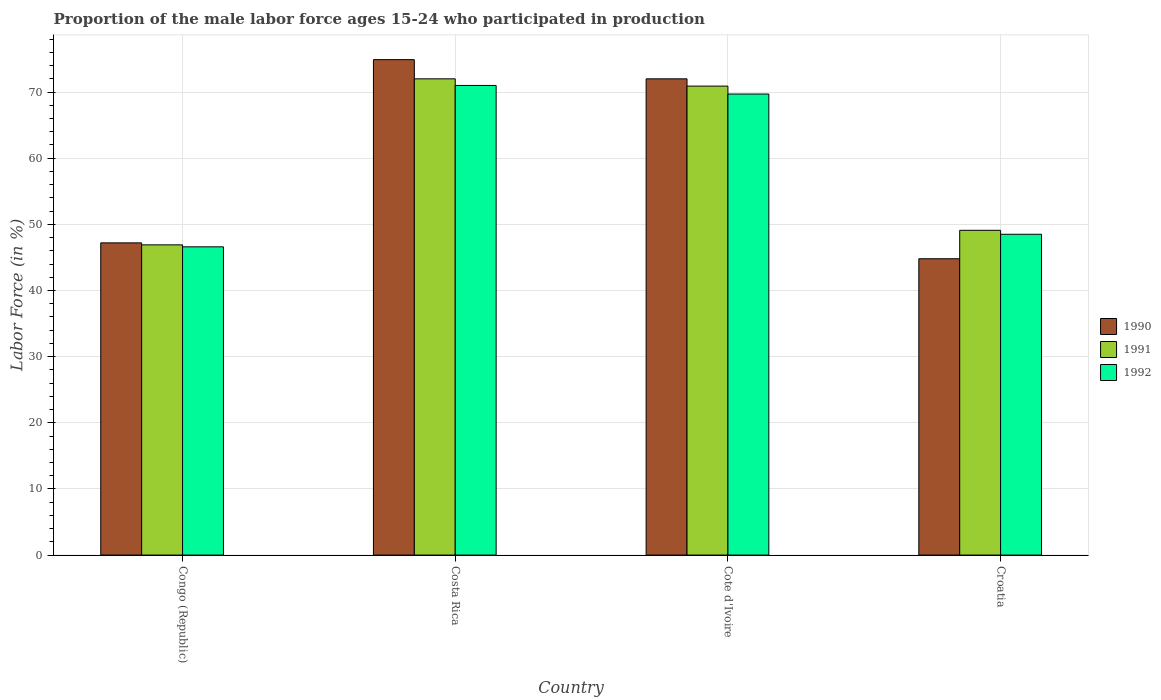How many groups of bars are there?
Provide a succinct answer. 4. How many bars are there on the 4th tick from the left?
Give a very brief answer. 3. What is the label of the 2nd group of bars from the left?
Ensure brevity in your answer.  Costa Rica. What is the proportion of the male labor force who participated in production in 1991 in Croatia?
Offer a terse response. 49.1. Across all countries, what is the minimum proportion of the male labor force who participated in production in 1991?
Your response must be concise. 46.9. In which country was the proportion of the male labor force who participated in production in 1992 minimum?
Offer a very short reply. Congo (Republic). What is the total proportion of the male labor force who participated in production in 1992 in the graph?
Offer a terse response. 235.8. What is the difference between the proportion of the male labor force who participated in production in 1992 in Congo (Republic) and that in Cote d'Ivoire?
Your response must be concise. -23.1. What is the difference between the proportion of the male labor force who participated in production in 1991 in Cote d'Ivoire and the proportion of the male labor force who participated in production in 1992 in Croatia?
Provide a succinct answer. 22.4. What is the average proportion of the male labor force who participated in production in 1991 per country?
Your response must be concise. 59.73. What is the difference between the proportion of the male labor force who participated in production of/in 1990 and proportion of the male labor force who participated in production of/in 1991 in Croatia?
Offer a very short reply. -4.3. What is the ratio of the proportion of the male labor force who participated in production in 1990 in Costa Rica to that in Croatia?
Your answer should be very brief. 1.67. What is the difference between the highest and the second highest proportion of the male labor force who participated in production in 1992?
Give a very brief answer. -21.2. What is the difference between the highest and the lowest proportion of the male labor force who participated in production in 1990?
Your response must be concise. 30.1. Is the sum of the proportion of the male labor force who participated in production in 1990 in Costa Rica and Cote d'Ivoire greater than the maximum proportion of the male labor force who participated in production in 1991 across all countries?
Keep it short and to the point. Yes. What does the 2nd bar from the right in Costa Rica represents?
Provide a short and direct response. 1991. Is it the case that in every country, the sum of the proportion of the male labor force who participated in production in 1991 and proportion of the male labor force who participated in production in 1992 is greater than the proportion of the male labor force who participated in production in 1990?
Your answer should be compact. Yes. Are all the bars in the graph horizontal?
Offer a very short reply. No. Are the values on the major ticks of Y-axis written in scientific E-notation?
Ensure brevity in your answer.  No. Does the graph contain any zero values?
Provide a short and direct response. No. Does the graph contain grids?
Ensure brevity in your answer.  Yes. How many legend labels are there?
Offer a very short reply. 3. How are the legend labels stacked?
Your answer should be compact. Vertical. What is the title of the graph?
Your response must be concise. Proportion of the male labor force ages 15-24 who participated in production. What is the Labor Force (in %) in 1990 in Congo (Republic)?
Ensure brevity in your answer.  47.2. What is the Labor Force (in %) of 1991 in Congo (Republic)?
Offer a terse response. 46.9. What is the Labor Force (in %) in 1992 in Congo (Republic)?
Your answer should be very brief. 46.6. What is the Labor Force (in %) of 1990 in Costa Rica?
Ensure brevity in your answer.  74.9. What is the Labor Force (in %) in 1991 in Costa Rica?
Provide a succinct answer. 72. What is the Labor Force (in %) in 1992 in Costa Rica?
Provide a short and direct response. 71. What is the Labor Force (in %) of 1990 in Cote d'Ivoire?
Your answer should be very brief. 72. What is the Labor Force (in %) of 1991 in Cote d'Ivoire?
Make the answer very short. 70.9. What is the Labor Force (in %) of 1992 in Cote d'Ivoire?
Offer a terse response. 69.7. What is the Labor Force (in %) in 1990 in Croatia?
Provide a succinct answer. 44.8. What is the Labor Force (in %) in 1991 in Croatia?
Provide a short and direct response. 49.1. What is the Labor Force (in %) in 1992 in Croatia?
Ensure brevity in your answer.  48.5. Across all countries, what is the maximum Labor Force (in %) of 1990?
Make the answer very short. 74.9. Across all countries, what is the maximum Labor Force (in %) of 1991?
Your answer should be very brief. 72. Across all countries, what is the minimum Labor Force (in %) in 1990?
Ensure brevity in your answer.  44.8. Across all countries, what is the minimum Labor Force (in %) in 1991?
Give a very brief answer. 46.9. Across all countries, what is the minimum Labor Force (in %) in 1992?
Your answer should be very brief. 46.6. What is the total Labor Force (in %) in 1990 in the graph?
Ensure brevity in your answer.  238.9. What is the total Labor Force (in %) of 1991 in the graph?
Your answer should be very brief. 238.9. What is the total Labor Force (in %) in 1992 in the graph?
Offer a terse response. 235.8. What is the difference between the Labor Force (in %) of 1990 in Congo (Republic) and that in Costa Rica?
Offer a terse response. -27.7. What is the difference between the Labor Force (in %) in 1991 in Congo (Republic) and that in Costa Rica?
Provide a succinct answer. -25.1. What is the difference between the Labor Force (in %) of 1992 in Congo (Republic) and that in Costa Rica?
Your answer should be very brief. -24.4. What is the difference between the Labor Force (in %) in 1990 in Congo (Republic) and that in Cote d'Ivoire?
Your answer should be very brief. -24.8. What is the difference between the Labor Force (in %) of 1992 in Congo (Republic) and that in Cote d'Ivoire?
Provide a succinct answer. -23.1. What is the difference between the Labor Force (in %) of 1991 in Congo (Republic) and that in Croatia?
Your answer should be compact. -2.2. What is the difference between the Labor Force (in %) of 1992 in Congo (Republic) and that in Croatia?
Your answer should be compact. -1.9. What is the difference between the Labor Force (in %) in 1990 in Costa Rica and that in Cote d'Ivoire?
Your response must be concise. 2.9. What is the difference between the Labor Force (in %) in 1991 in Costa Rica and that in Cote d'Ivoire?
Keep it short and to the point. 1.1. What is the difference between the Labor Force (in %) of 1992 in Costa Rica and that in Cote d'Ivoire?
Your response must be concise. 1.3. What is the difference between the Labor Force (in %) in 1990 in Costa Rica and that in Croatia?
Give a very brief answer. 30.1. What is the difference between the Labor Force (in %) of 1991 in Costa Rica and that in Croatia?
Make the answer very short. 22.9. What is the difference between the Labor Force (in %) in 1990 in Cote d'Ivoire and that in Croatia?
Give a very brief answer. 27.2. What is the difference between the Labor Force (in %) in 1991 in Cote d'Ivoire and that in Croatia?
Ensure brevity in your answer.  21.8. What is the difference between the Labor Force (in %) in 1992 in Cote d'Ivoire and that in Croatia?
Provide a succinct answer. 21.2. What is the difference between the Labor Force (in %) of 1990 in Congo (Republic) and the Labor Force (in %) of 1991 in Costa Rica?
Keep it short and to the point. -24.8. What is the difference between the Labor Force (in %) of 1990 in Congo (Republic) and the Labor Force (in %) of 1992 in Costa Rica?
Provide a succinct answer. -23.8. What is the difference between the Labor Force (in %) in 1991 in Congo (Republic) and the Labor Force (in %) in 1992 in Costa Rica?
Your response must be concise. -24.1. What is the difference between the Labor Force (in %) of 1990 in Congo (Republic) and the Labor Force (in %) of 1991 in Cote d'Ivoire?
Your response must be concise. -23.7. What is the difference between the Labor Force (in %) in 1990 in Congo (Republic) and the Labor Force (in %) in 1992 in Cote d'Ivoire?
Offer a terse response. -22.5. What is the difference between the Labor Force (in %) of 1991 in Congo (Republic) and the Labor Force (in %) of 1992 in Cote d'Ivoire?
Give a very brief answer. -22.8. What is the difference between the Labor Force (in %) in 1990 in Congo (Republic) and the Labor Force (in %) in 1991 in Croatia?
Offer a very short reply. -1.9. What is the difference between the Labor Force (in %) of 1991 in Congo (Republic) and the Labor Force (in %) of 1992 in Croatia?
Your answer should be compact. -1.6. What is the difference between the Labor Force (in %) in 1991 in Costa Rica and the Labor Force (in %) in 1992 in Cote d'Ivoire?
Ensure brevity in your answer.  2.3. What is the difference between the Labor Force (in %) in 1990 in Costa Rica and the Labor Force (in %) in 1991 in Croatia?
Keep it short and to the point. 25.8. What is the difference between the Labor Force (in %) of 1990 in Costa Rica and the Labor Force (in %) of 1992 in Croatia?
Ensure brevity in your answer.  26.4. What is the difference between the Labor Force (in %) in 1990 in Cote d'Ivoire and the Labor Force (in %) in 1991 in Croatia?
Your answer should be very brief. 22.9. What is the difference between the Labor Force (in %) of 1991 in Cote d'Ivoire and the Labor Force (in %) of 1992 in Croatia?
Your response must be concise. 22.4. What is the average Labor Force (in %) of 1990 per country?
Your answer should be compact. 59.73. What is the average Labor Force (in %) in 1991 per country?
Ensure brevity in your answer.  59.73. What is the average Labor Force (in %) in 1992 per country?
Give a very brief answer. 58.95. What is the difference between the Labor Force (in %) of 1990 and Labor Force (in %) of 1991 in Congo (Republic)?
Provide a succinct answer. 0.3. What is the difference between the Labor Force (in %) in 1990 and Labor Force (in %) in 1992 in Congo (Republic)?
Keep it short and to the point. 0.6. What is the difference between the Labor Force (in %) in 1991 and Labor Force (in %) in 1992 in Congo (Republic)?
Provide a short and direct response. 0.3. What is the difference between the Labor Force (in %) in 1990 and Labor Force (in %) in 1992 in Costa Rica?
Your answer should be very brief. 3.9. What is the difference between the Labor Force (in %) in 1991 and Labor Force (in %) in 1992 in Costa Rica?
Ensure brevity in your answer.  1. What is the difference between the Labor Force (in %) of 1990 and Labor Force (in %) of 1992 in Cote d'Ivoire?
Ensure brevity in your answer.  2.3. What is the difference between the Labor Force (in %) in 1991 and Labor Force (in %) in 1992 in Cote d'Ivoire?
Your answer should be very brief. 1.2. What is the difference between the Labor Force (in %) in 1990 and Labor Force (in %) in 1992 in Croatia?
Offer a very short reply. -3.7. What is the ratio of the Labor Force (in %) in 1990 in Congo (Republic) to that in Costa Rica?
Make the answer very short. 0.63. What is the ratio of the Labor Force (in %) of 1991 in Congo (Republic) to that in Costa Rica?
Keep it short and to the point. 0.65. What is the ratio of the Labor Force (in %) of 1992 in Congo (Republic) to that in Costa Rica?
Your response must be concise. 0.66. What is the ratio of the Labor Force (in %) in 1990 in Congo (Republic) to that in Cote d'Ivoire?
Your answer should be very brief. 0.66. What is the ratio of the Labor Force (in %) in 1991 in Congo (Republic) to that in Cote d'Ivoire?
Your answer should be compact. 0.66. What is the ratio of the Labor Force (in %) in 1992 in Congo (Republic) to that in Cote d'Ivoire?
Keep it short and to the point. 0.67. What is the ratio of the Labor Force (in %) of 1990 in Congo (Republic) to that in Croatia?
Keep it short and to the point. 1.05. What is the ratio of the Labor Force (in %) of 1991 in Congo (Republic) to that in Croatia?
Ensure brevity in your answer.  0.96. What is the ratio of the Labor Force (in %) of 1992 in Congo (Republic) to that in Croatia?
Your answer should be compact. 0.96. What is the ratio of the Labor Force (in %) of 1990 in Costa Rica to that in Cote d'Ivoire?
Ensure brevity in your answer.  1.04. What is the ratio of the Labor Force (in %) of 1991 in Costa Rica to that in Cote d'Ivoire?
Provide a succinct answer. 1.02. What is the ratio of the Labor Force (in %) in 1992 in Costa Rica to that in Cote d'Ivoire?
Ensure brevity in your answer.  1.02. What is the ratio of the Labor Force (in %) in 1990 in Costa Rica to that in Croatia?
Provide a short and direct response. 1.67. What is the ratio of the Labor Force (in %) in 1991 in Costa Rica to that in Croatia?
Your answer should be compact. 1.47. What is the ratio of the Labor Force (in %) in 1992 in Costa Rica to that in Croatia?
Give a very brief answer. 1.46. What is the ratio of the Labor Force (in %) of 1990 in Cote d'Ivoire to that in Croatia?
Provide a succinct answer. 1.61. What is the ratio of the Labor Force (in %) in 1991 in Cote d'Ivoire to that in Croatia?
Your answer should be compact. 1.44. What is the ratio of the Labor Force (in %) in 1992 in Cote d'Ivoire to that in Croatia?
Keep it short and to the point. 1.44. What is the difference between the highest and the second highest Labor Force (in %) of 1990?
Your answer should be compact. 2.9. What is the difference between the highest and the lowest Labor Force (in %) of 1990?
Offer a very short reply. 30.1. What is the difference between the highest and the lowest Labor Force (in %) of 1991?
Ensure brevity in your answer.  25.1. What is the difference between the highest and the lowest Labor Force (in %) in 1992?
Provide a succinct answer. 24.4. 